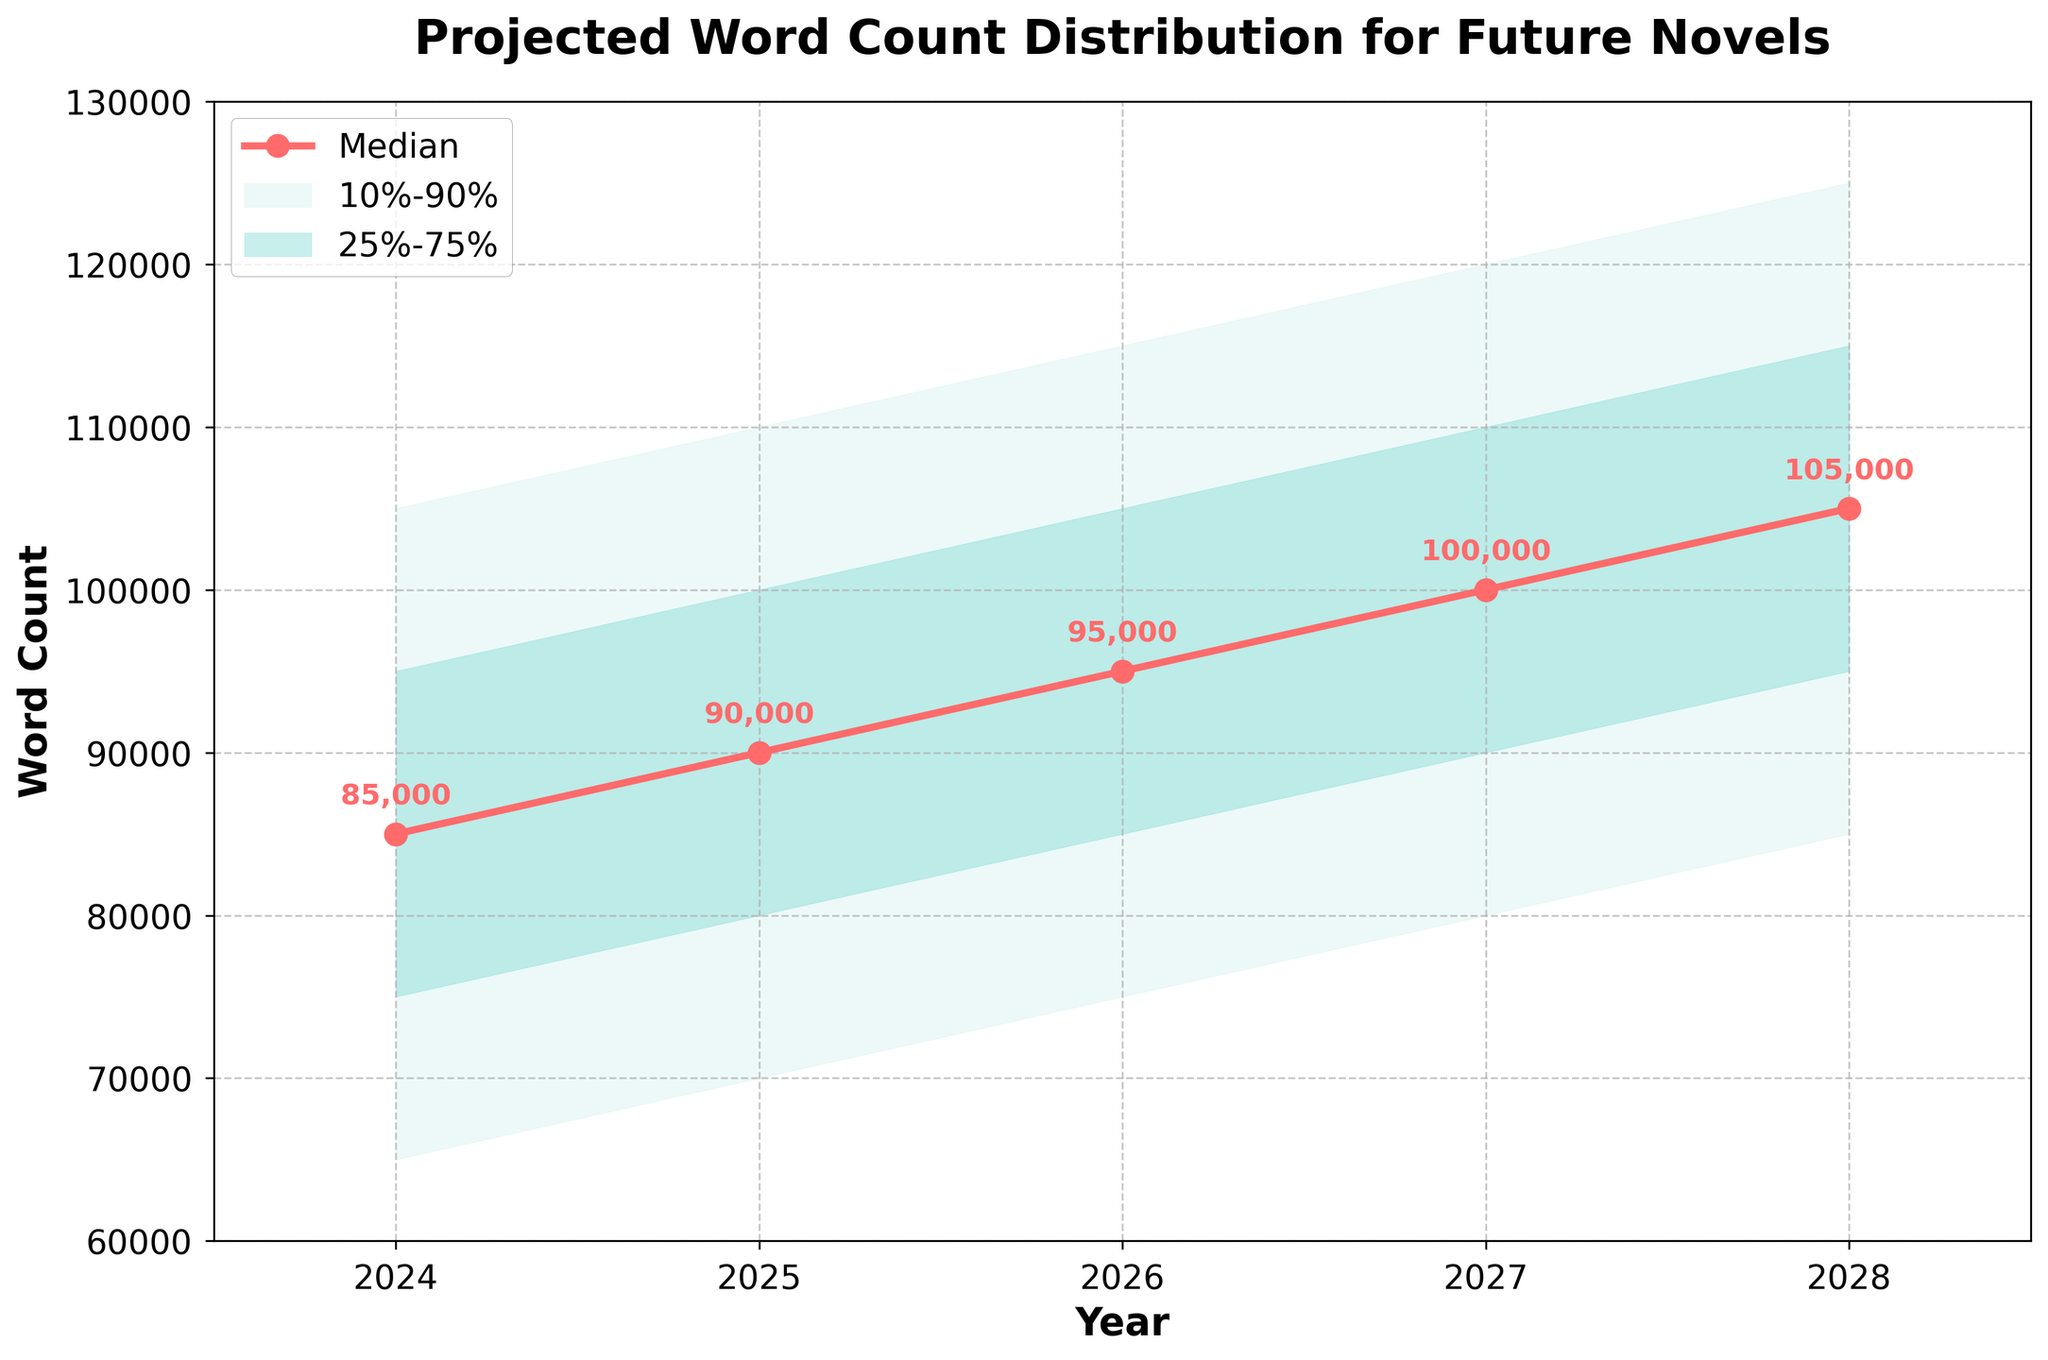What's the title of the fan chart? The title of the fan chart is displayed at the top of the figure. It is labeled as 'Projected Word Count Distribution for Future Novels.'
Answer: Projected Word Count Distribution for Future Novels What's the median projected word count for the year 2026? The median projected word count for 2026 can be seen along the median line, which is labeled for each year. For 2026, the median value annotated is 95,000.
Answer: 95,000 What is the range of the projected word count between the lower 10% and upper 10% for 2024? In 2024, the lower 10% value is 65,000 and the upper 10% value is 105,000. The range is calculated as the difference between these two values: 105,000 - 65,000 = 40,000.
Answer: 40,000 Which year shows the highest median projected word count? To determine the year with the highest median, we look at the median values annotated on the median line. For 2028, the median value is highest at 105,000.
Answer: 2028 What is the difference between the upper 25% and the lower 25% values for 2025? For 2025, the upper 25% value is 100,000 and the lower 25% value is 80,000. The difference is calculated as follows: 100,000 - 80,000 = 20,000.
Answer: 20,000 How does the projected median word count change from 2024 to 2028? Observing the median values from 2024 to 2028, they increase from 85,000 to 105,000. The change is 105,000 - 85,000 = 20,000, indicating an increasing trend.
Answer: Increases by 20,000 Which percentile range is shaded with higher opacity, 10%-90% or 25%-75%? The figure shows that the 25%-75% percentile range is shaded with higher opacity compared to the 10%-90% percentile range. This is indicated by the alpha value settings in the shading.
Answer: 25%-75% In 2027, what are the projected word counts at the lower 10% and upper 90%? For 2027, the lower 10% value is 80,000 and the upper 90% value is 120,000. These values can be read directly from the plot.
Answer: Lower 10%: 80,000, Upper 90%: 120,000 